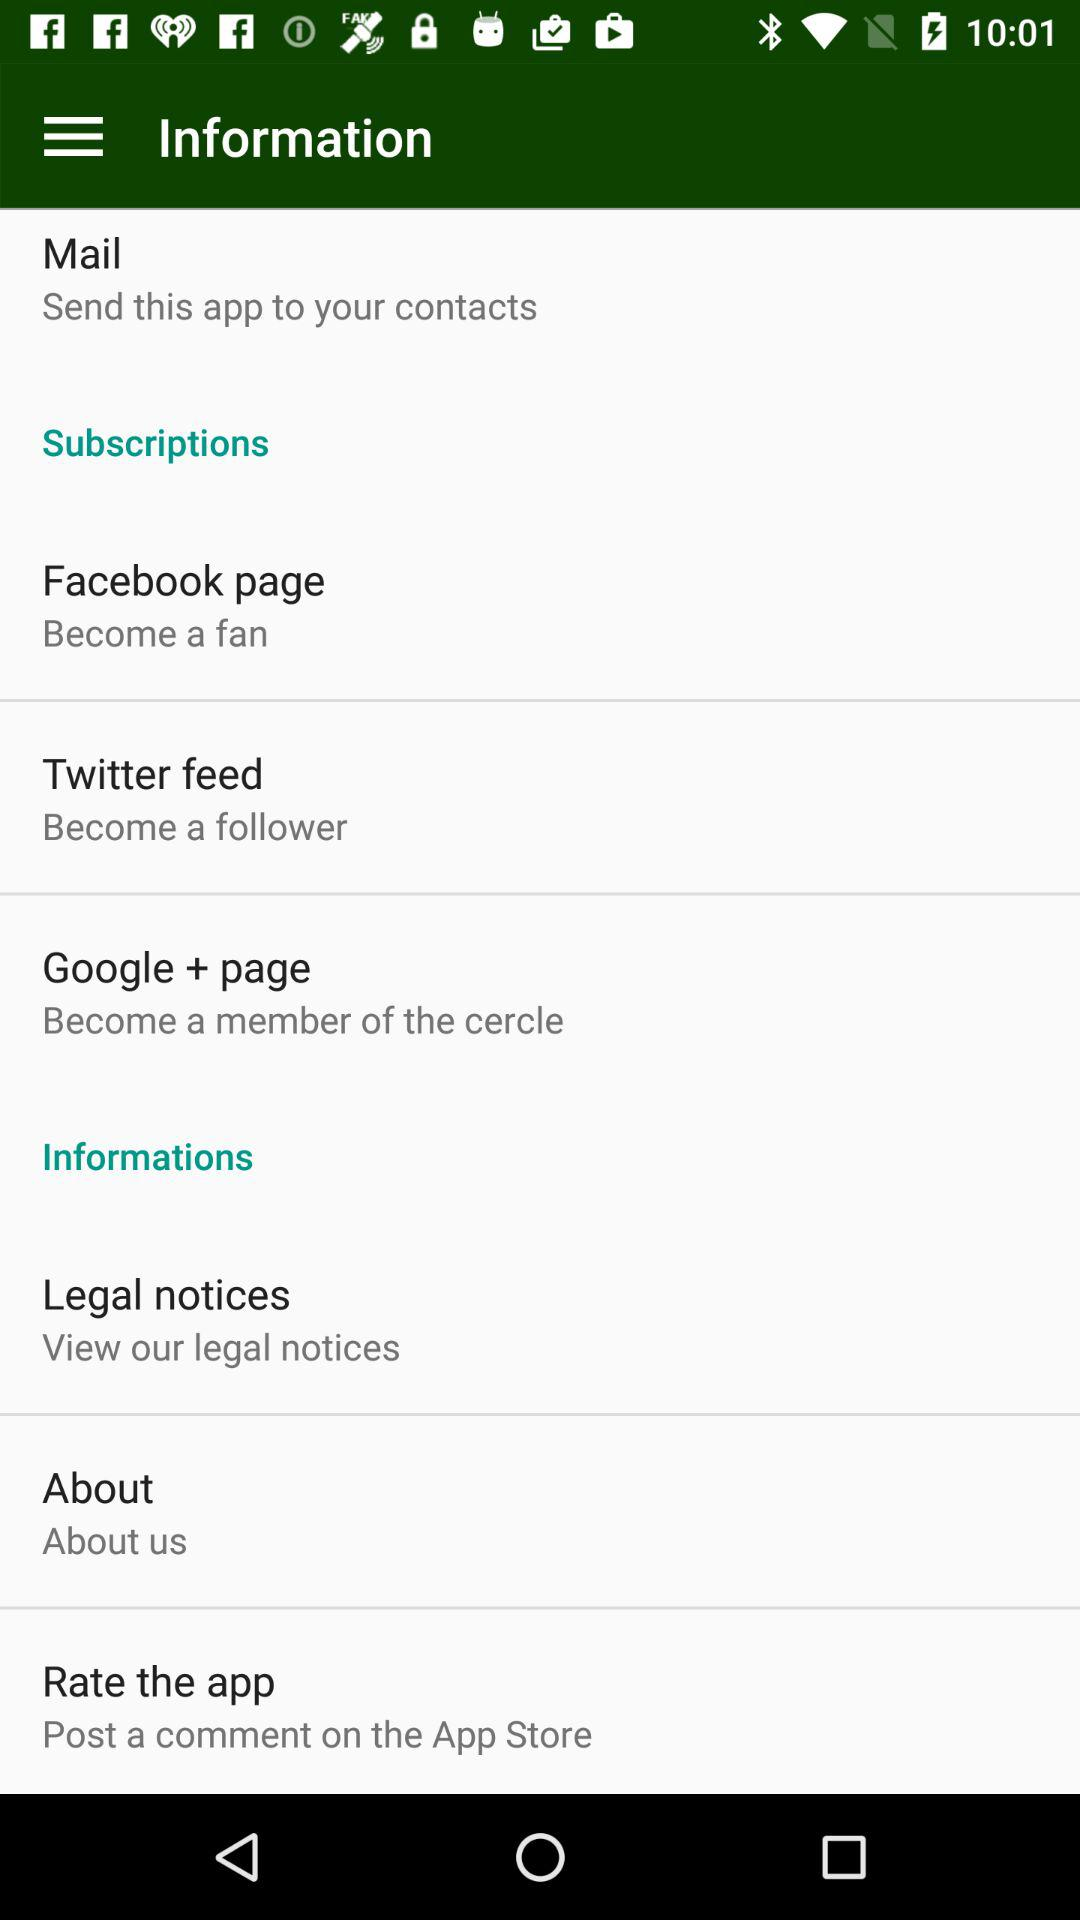Where can I rate the application? You can rate the application on the "App Store". 